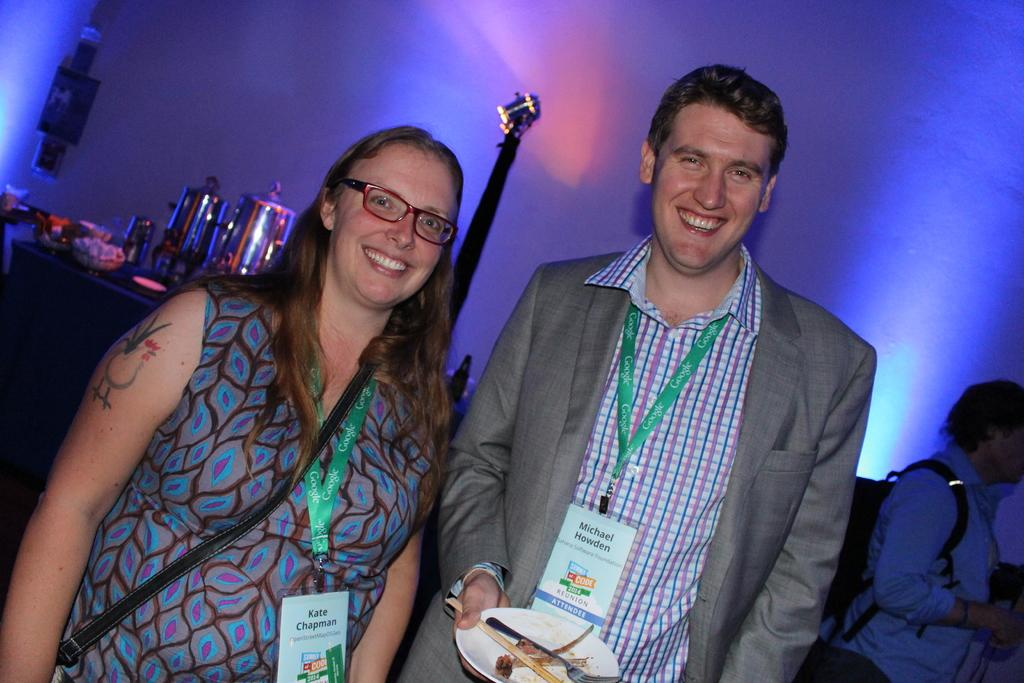What are the two people in the image doing? The two people in the image are standing and smiling. Can you describe what one of the people is holding? One person is carrying a bag. What is the other person holding? The other person is holding a plate with a fork and food. What can be seen in the background of the image? In the background, there are people and objects visible. Are there any specific details about the people or objects in the background? The facts provided do not give specific details about the people or objects in the background. What type of wilderness can be seen in the background of the image? There is no wilderness visible in the background of the image; it features people and objects. How many parents are present in the image? The facts provided do not give any information about parents in the image. 